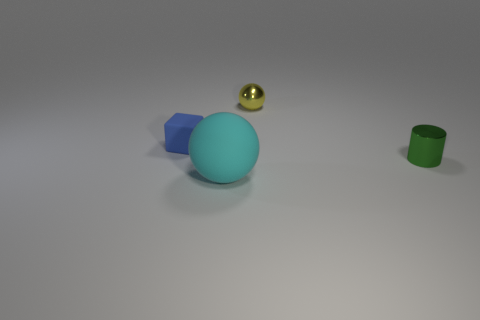What material is the object that is to the right of the metal thing left of the small thing that is to the right of the tiny yellow metallic thing?
Ensure brevity in your answer.  Metal. Are there more large matte objects than balls?
Offer a terse response. No. What size is the object that is the same material as the tiny blue block?
Your response must be concise. Large. What is the small yellow object made of?
Your answer should be very brief. Metal. How many yellow matte balls are the same size as the green cylinder?
Your response must be concise. 0. Are there any big gray objects that have the same shape as the blue object?
Provide a short and direct response. No. There is a metal sphere that is the same size as the blue object; what color is it?
Your answer should be very brief. Yellow. There is a tiny object on the right side of the small shiny thing left of the tiny green object; what color is it?
Offer a terse response. Green. What shape is the shiny thing that is right of the sphere that is behind the matte ball in front of the green object?
Ensure brevity in your answer.  Cylinder. There is a small blue object that is behind the cyan matte sphere; what number of small cylinders are left of it?
Ensure brevity in your answer.  0. 